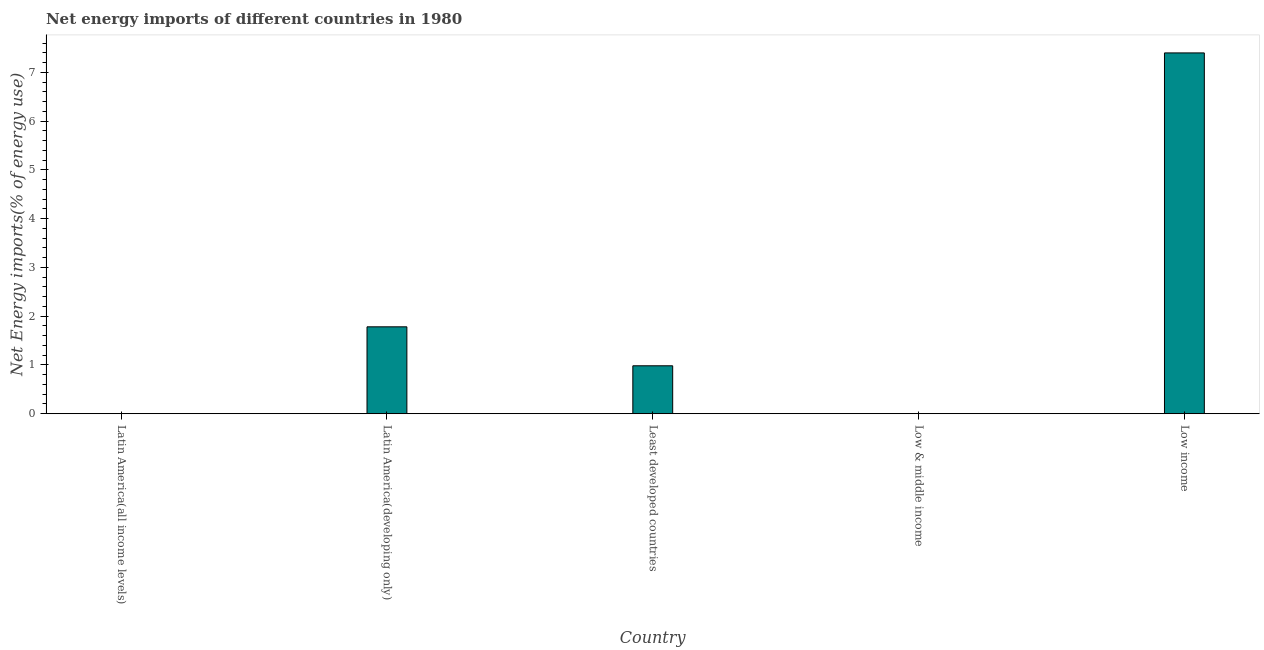Does the graph contain grids?
Keep it short and to the point. No. What is the title of the graph?
Offer a terse response. Net energy imports of different countries in 1980. What is the label or title of the X-axis?
Your answer should be very brief. Country. What is the label or title of the Y-axis?
Provide a short and direct response. Net Energy imports(% of energy use). What is the energy imports in Latin America(all income levels)?
Give a very brief answer. 0. Across all countries, what is the maximum energy imports?
Your answer should be very brief. 7.4. What is the sum of the energy imports?
Make the answer very short. 10.17. What is the difference between the energy imports in Least developed countries and Low income?
Your response must be concise. -6.42. What is the average energy imports per country?
Provide a short and direct response. 2.03. What is the median energy imports?
Keep it short and to the point. 0.98. In how many countries, is the energy imports greater than 3.2 %?
Offer a terse response. 1. What is the ratio of the energy imports in Latin America(developing only) to that in Low income?
Ensure brevity in your answer.  0.24. What is the difference between the highest and the second highest energy imports?
Your answer should be very brief. 5.62. What is the difference between the highest and the lowest energy imports?
Provide a short and direct response. 7.4. In how many countries, is the energy imports greater than the average energy imports taken over all countries?
Give a very brief answer. 1. How many bars are there?
Your answer should be very brief. 3. What is the Net Energy imports(% of energy use) of Latin America(all income levels)?
Provide a succinct answer. 0. What is the Net Energy imports(% of energy use) of Latin America(developing only)?
Keep it short and to the point. 1.78. What is the Net Energy imports(% of energy use) of Least developed countries?
Keep it short and to the point. 0.98. What is the Net Energy imports(% of energy use) of Low income?
Offer a very short reply. 7.4. What is the difference between the Net Energy imports(% of energy use) in Latin America(developing only) and Least developed countries?
Your response must be concise. 0.8. What is the difference between the Net Energy imports(% of energy use) in Latin America(developing only) and Low income?
Provide a succinct answer. -5.62. What is the difference between the Net Energy imports(% of energy use) in Least developed countries and Low income?
Make the answer very short. -6.42. What is the ratio of the Net Energy imports(% of energy use) in Latin America(developing only) to that in Least developed countries?
Your answer should be compact. 1.81. What is the ratio of the Net Energy imports(% of energy use) in Latin America(developing only) to that in Low income?
Give a very brief answer. 0.24. What is the ratio of the Net Energy imports(% of energy use) in Least developed countries to that in Low income?
Ensure brevity in your answer.  0.13. 